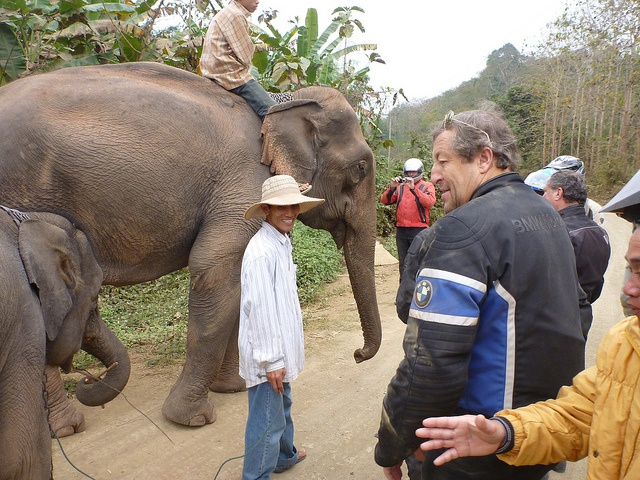Describe the objects in this image and their specific colors. I can see elephant in darkgreen, gray, and darkgray tones, people in darkgreen, black, gray, navy, and darkgray tones, elephant in darkgreen, gray, maroon, and black tones, people in darkgreen, lightgray, gray, and darkgray tones, and people in darkgreen, tan, olive, and salmon tones in this image. 